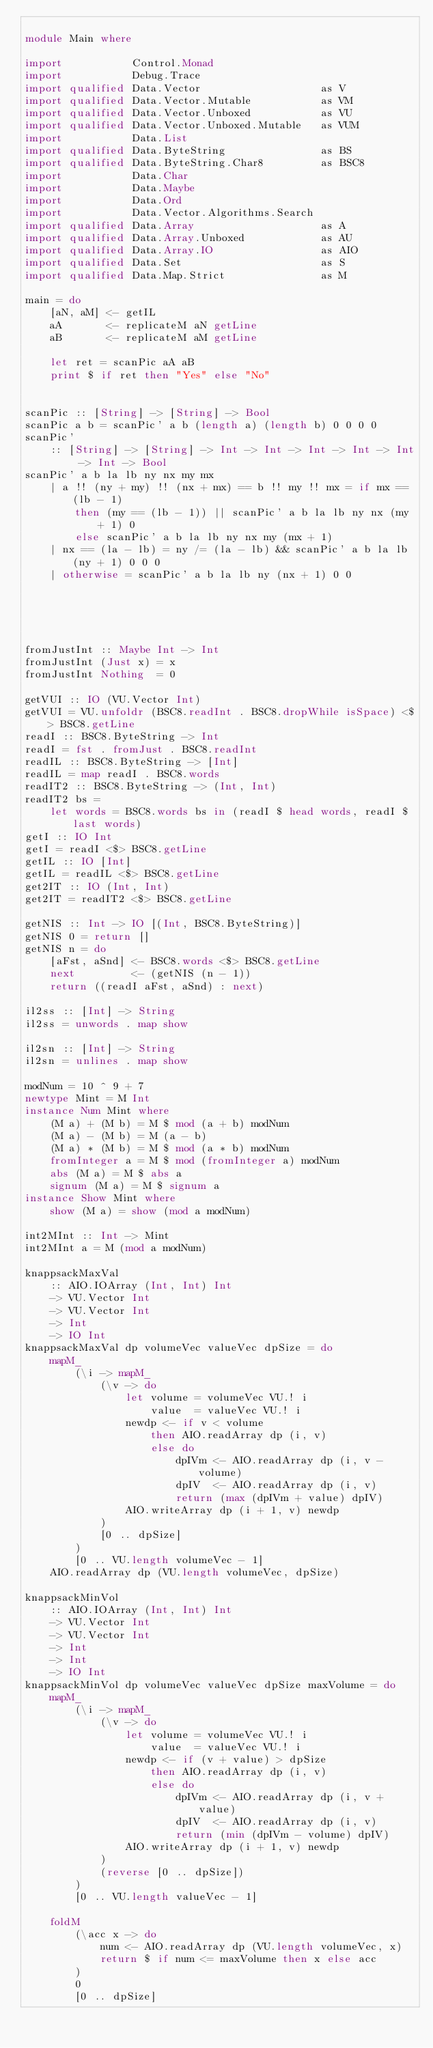<code> <loc_0><loc_0><loc_500><loc_500><_Haskell_>
module Main where

import           Control.Monad
import           Debug.Trace
import qualified Data.Vector                   as V
import qualified Data.Vector.Mutable           as VM
import qualified Data.Vector.Unboxed           as VU
import qualified Data.Vector.Unboxed.Mutable   as VUM
import           Data.List
import qualified Data.ByteString               as BS
import qualified Data.ByteString.Char8         as BSC8
import           Data.Char
import           Data.Maybe
import           Data.Ord
import           Data.Vector.Algorithms.Search
import qualified Data.Array                    as A
import qualified Data.Array.Unboxed            as AU
import qualified Data.Array.IO                 as AIO
import qualified Data.Set                      as S
import qualified Data.Map.Strict               as M

main = do
    [aN, aM] <- getIL
    aA       <- replicateM aN getLine
    aB       <- replicateM aM getLine

    let ret = scanPic aA aB
    print $ if ret then "Yes" else "No"


scanPic :: [String] -> [String] -> Bool
scanPic a b = scanPic' a b (length a) (length b) 0 0 0 0
scanPic'
    :: [String] -> [String] -> Int -> Int -> Int -> Int -> Int -> Int -> Bool
scanPic' a b la lb ny nx my mx
    | a !! (ny + my) !! (nx + mx) == b !! my !! mx = if mx == (lb - 1)
        then (my == (lb - 1)) || scanPic' a b la lb ny nx (my + 1) 0
        else scanPic' a b la lb ny nx my (mx + 1)
    | nx == (la - lb) = ny /= (la - lb) && scanPic' a b la lb (ny + 1) 0 0 0
    | otherwise = scanPic' a b la lb ny (nx + 1) 0 0





fromJustInt :: Maybe Int -> Int
fromJustInt (Just x) = x
fromJustInt Nothing  = 0

getVUI :: IO (VU.Vector Int)
getVUI = VU.unfoldr (BSC8.readInt . BSC8.dropWhile isSpace) <$> BSC8.getLine
readI :: BSC8.ByteString -> Int
readI = fst . fromJust . BSC8.readInt
readIL :: BSC8.ByteString -> [Int]
readIL = map readI . BSC8.words
readIT2 :: BSC8.ByteString -> (Int, Int)
readIT2 bs =
    let words = BSC8.words bs in (readI $ head words, readI $ last words)
getI :: IO Int
getI = readI <$> BSC8.getLine
getIL :: IO [Int]
getIL = readIL <$> BSC8.getLine
get2IT :: IO (Int, Int)
get2IT = readIT2 <$> BSC8.getLine

getNIS :: Int -> IO [(Int, BSC8.ByteString)]
getNIS 0 = return []
getNIS n = do
    [aFst, aSnd] <- BSC8.words <$> BSC8.getLine
    next         <- (getNIS (n - 1))
    return ((readI aFst, aSnd) : next)

il2ss :: [Int] -> String
il2ss = unwords . map show

il2sn :: [Int] -> String
il2sn = unlines . map show

modNum = 10 ^ 9 + 7
newtype Mint = M Int
instance Num Mint where
    (M a) + (M b) = M $ mod (a + b) modNum
    (M a) - (M b) = M (a - b)
    (M a) * (M b) = M $ mod (a * b) modNum
    fromInteger a = M $ mod (fromInteger a) modNum
    abs (M a) = M $ abs a
    signum (M a) = M $ signum a
instance Show Mint where
    show (M a) = show (mod a modNum)

int2MInt :: Int -> Mint
int2MInt a = M (mod a modNum)

knappsackMaxVal
    :: AIO.IOArray (Int, Int) Int
    -> VU.Vector Int
    -> VU.Vector Int
    -> Int
    -> IO Int
knappsackMaxVal dp volumeVec valueVec dpSize = do
    mapM_
        (\i -> mapM_
            (\v -> do
                let volume = volumeVec VU.! i
                    value  = valueVec VU.! i
                newdp <- if v < volume
                    then AIO.readArray dp (i, v)
                    else do
                        dpIVm <- AIO.readArray dp (i, v - volume)
                        dpIV  <- AIO.readArray dp (i, v)
                        return (max (dpIVm + value) dpIV)
                AIO.writeArray dp (i + 1, v) newdp
            )
            [0 .. dpSize]
        )
        [0 .. VU.length volumeVec - 1]
    AIO.readArray dp (VU.length volumeVec, dpSize)

knappsackMinVol
    :: AIO.IOArray (Int, Int) Int
    -> VU.Vector Int
    -> VU.Vector Int
    -> Int
    -> Int
    -> IO Int
knappsackMinVol dp volumeVec valueVec dpSize maxVolume = do
    mapM_
        (\i -> mapM_
            (\v -> do
                let volume = volumeVec VU.! i
                    value  = valueVec VU.! i
                newdp <- if (v + value) > dpSize
                    then AIO.readArray dp (i, v)
                    else do
                        dpIVm <- AIO.readArray dp (i, v + value)
                        dpIV  <- AIO.readArray dp (i, v)
                        return (min (dpIVm - volume) dpIV)
                AIO.writeArray dp (i + 1, v) newdp
            )
            (reverse [0 .. dpSize])
        )
        [0 .. VU.length valueVec - 1]

    foldM
        (\acc x -> do
            num <- AIO.readArray dp (VU.length volumeVec, x)
            return $ if num <= maxVolume then x else acc
        )
        0
        [0 .. dpSize]

</code> 